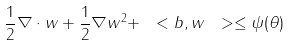Convert formula to latex. <formula><loc_0><loc_0><loc_500><loc_500>\frac { 1 } { 2 } \nabla \cdot w + \frac { 1 } { 2 } \| \nabla w \| ^ { 2 } + \ < b , w \ > \leq \psi ( \theta )</formula> 